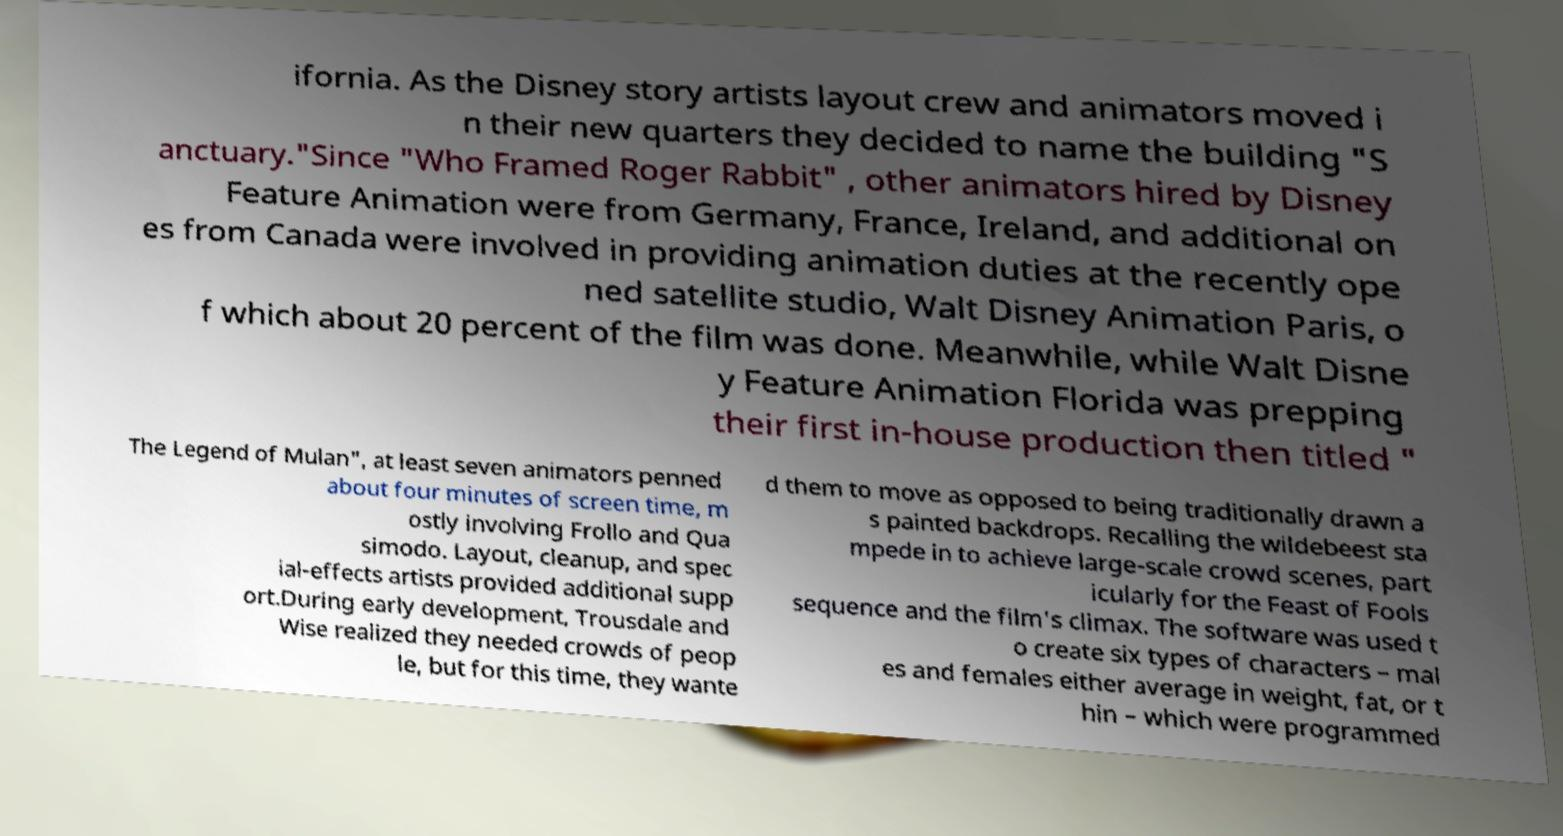Could you extract and type out the text from this image? ifornia. As the Disney story artists layout crew and animators moved i n their new quarters they decided to name the building "S anctuary."Since "Who Framed Roger Rabbit" , other animators hired by Disney Feature Animation were from Germany, France, Ireland, and additional on es from Canada were involved in providing animation duties at the recently ope ned satellite studio, Walt Disney Animation Paris, o f which about 20 percent of the film was done. Meanwhile, while Walt Disne y Feature Animation Florida was prepping their first in-house production then titled " The Legend of Mulan", at least seven animators penned about four minutes of screen time, m ostly involving Frollo and Qua simodo. Layout, cleanup, and spec ial-effects artists provided additional supp ort.During early development, Trousdale and Wise realized they needed crowds of peop le, but for this time, they wante d them to move as opposed to being traditionally drawn a s painted backdrops. Recalling the wildebeest sta mpede in to achieve large-scale crowd scenes, part icularly for the Feast of Fools sequence and the film's climax. The software was used t o create six types of characters – mal es and females either average in weight, fat, or t hin – which were programmed 